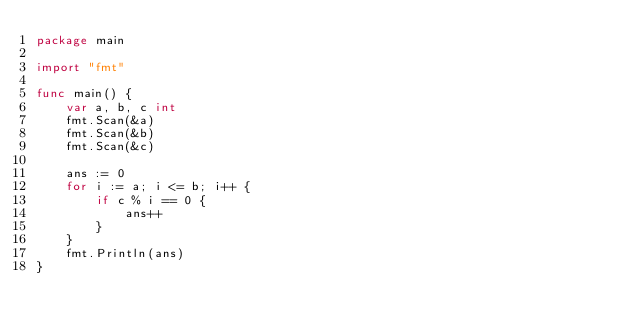Convert code to text. <code><loc_0><loc_0><loc_500><loc_500><_Go_>package main

import "fmt"

func main() {
	var a, b, c int
	fmt.Scan(&a)
	fmt.Scan(&b)
	fmt.Scan(&c)

	ans := 0
	for i := a; i <= b; i++ {
		if c % i == 0 {
			ans++
		}
	}
	fmt.Println(ans)
}
</code> 